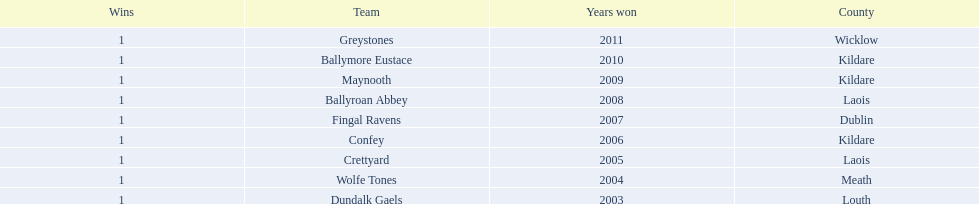Which team won after ballymore eustace? Greystones. 